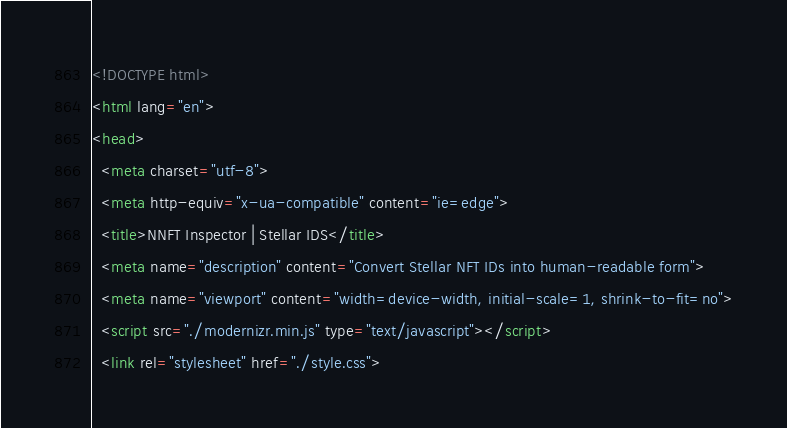Convert code to text. <code><loc_0><loc_0><loc_500><loc_500><_HTML_><!DOCTYPE html>
<html lang="en">
<head>
  <meta charset="utf-8">
  <meta http-equiv="x-ua-compatible" content="ie=edge">
  <title>NNFT Inspector | Stellar IDS</title>
  <meta name="description" content="Convert Stellar NFT IDs into human-readable form">
  <meta name="viewport" content="width=device-width, initial-scale=1, shrink-to-fit=no">
  <script src="./modernizr.min.js" type="text/javascript"></script>
  <link rel="stylesheet" href="./style.css"></code> 